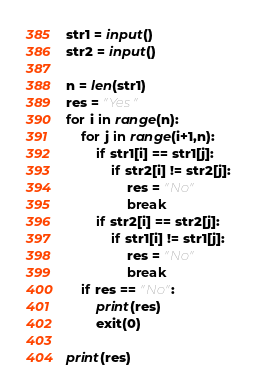<code> <loc_0><loc_0><loc_500><loc_500><_Python_>str1 = input()
str2 = input()

n = len(str1)
res = "Yes"
for i in range(n):
    for j in range(i+1,n):
        if str1[i] == str1[j]:
            if str2[i] != str2[j]:
                res = "No"
                break
        if str2[i] == str2[j]:
            if str1[i] != str1[j]:
                res = "No"
                break
    if res == "No":
        print(res)
        exit(0)

print(res)
</code> 